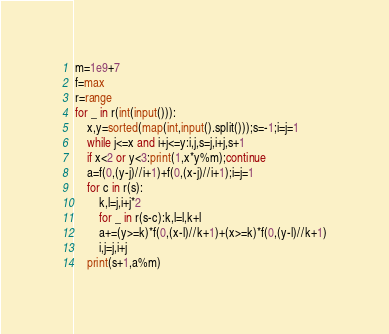Convert code to text. <code><loc_0><loc_0><loc_500><loc_500><_Python_>m=1e9+7
f=max
r=range
for _ in r(int(input())):
	x,y=sorted(map(int,input().split()));s=-1;i=j=1
	while j<=x and i+j<=y:i,j,s=j,i+j,s+1
	if x<2 or y<3:print(1,x*y%m);continue
	a=f(0,(y-j)//i+1)+f(0,(x-j)//i+1);i=j=1
	for c in r(s):
		k,l=j,i+j*2
		for _ in r(s-c):k,l=l,k+l
		a+=(y>=k)*f(0,(x-l)//k+1)+(x>=k)*f(0,(y-l)//k+1)
		i,j=j,i+j
	print(s+1,a%m)</code> 